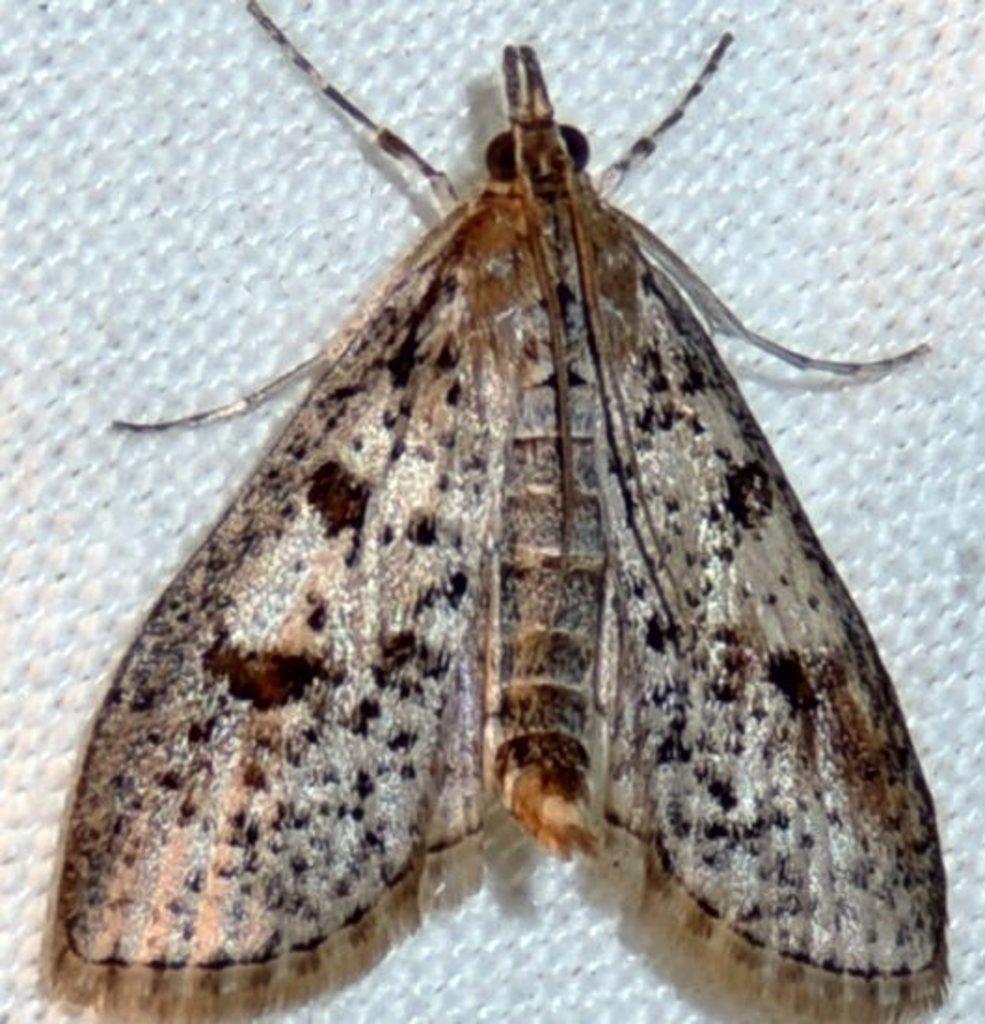Describe this image in one or two sentences. In this image we can see one insect and there is a white background. 